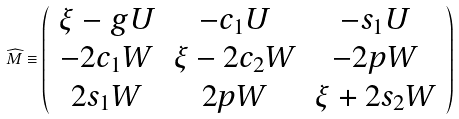<formula> <loc_0><loc_0><loc_500><loc_500>\widehat { M } \equiv \left ( \begin{array} { c c c } \xi - g U & - c _ { 1 } U & - s _ { 1 } U \\ - 2 c _ { 1 } W & \xi - 2 c _ { 2 } W & - 2 p W \\ 2 s _ { 1 } W & 2 p W & \xi + 2 s _ { 2 } W \end{array} \right )</formula> 